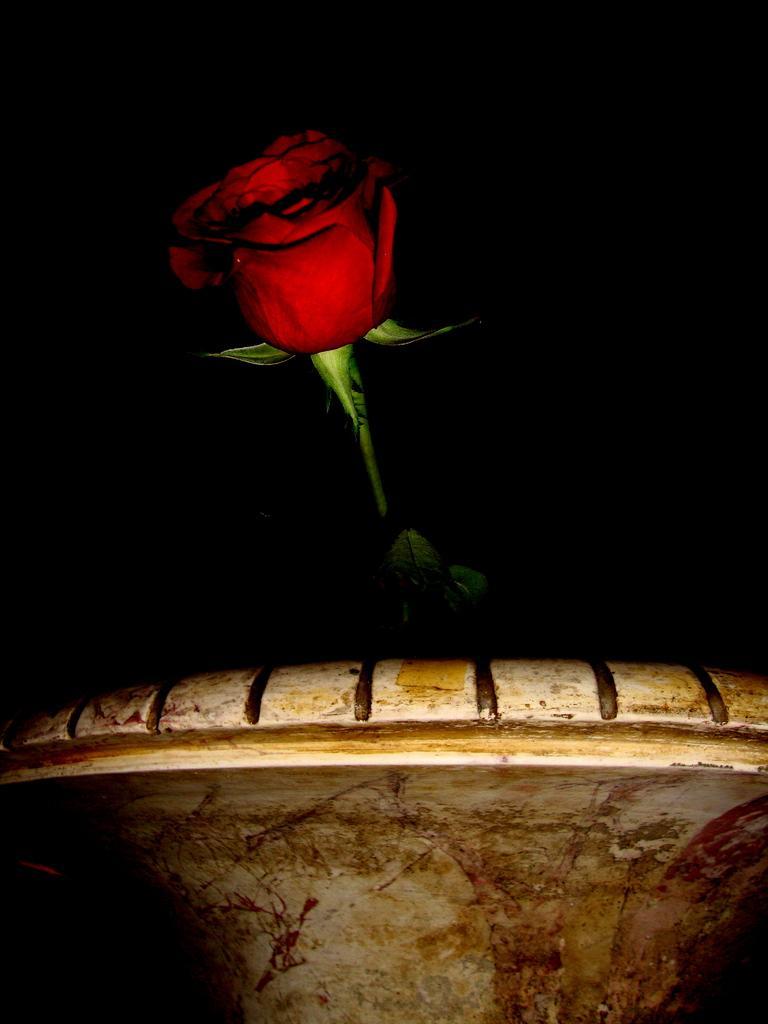Please provide a concise description of this image. In this picture we can see the red color rose. In the front bottom side we can see chair. Behind there is a black background. 